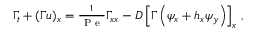Convert formula to latex. <formula><loc_0><loc_0><loc_500><loc_500>\begin{array} { r } { \Gamma _ { t } + ( \Gamma u ) _ { x } = \frac { 1 } { P e } \Gamma _ { x x } - D \left [ \Gamma \left ( \psi _ { x } + h _ { x } \psi _ { y } \right ) \right ] _ { x } \, , } \end{array}</formula> 